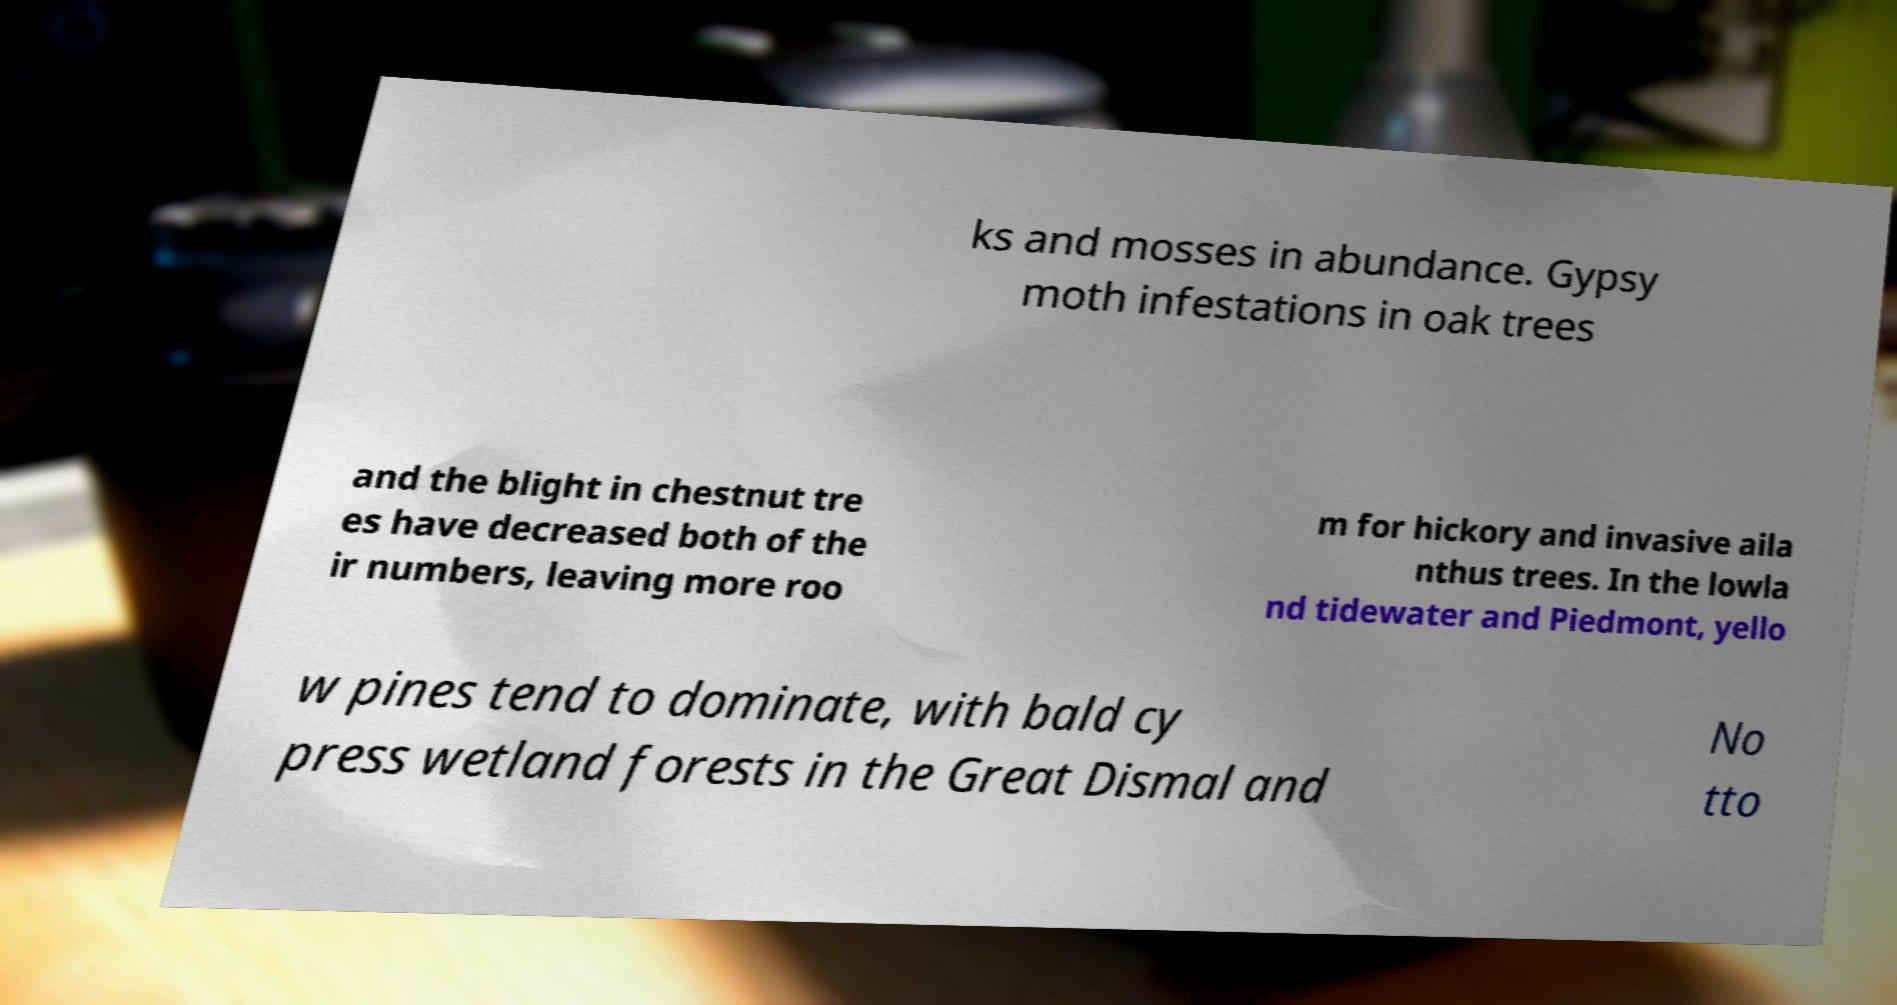There's text embedded in this image that I need extracted. Can you transcribe it verbatim? ks and mosses in abundance. Gypsy moth infestations in oak trees and the blight in chestnut tre es have decreased both of the ir numbers, leaving more roo m for hickory and invasive aila nthus trees. In the lowla nd tidewater and Piedmont, yello w pines tend to dominate, with bald cy press wetland forests in the Great Dismal and No tto 